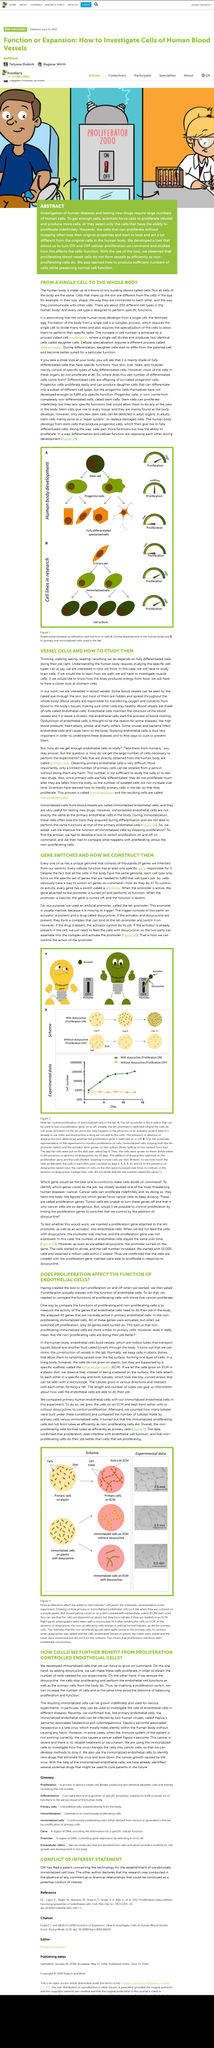Draw attention to some important aspects in this diagram. When studying how the body produces energy, it is necessary to investigate stomach cells to understand the process of digestion. The activation of 34 genes indicated that non-dividing immortalized cells were more similar to primary cells than previously thought. When investigating different body functions, it is necessary to study specific cells in order to understand their individual functions. The article is about gene switches. The cells in a human body are not all the same, as they vary greatly in terms of their individual characteristics and functions. 